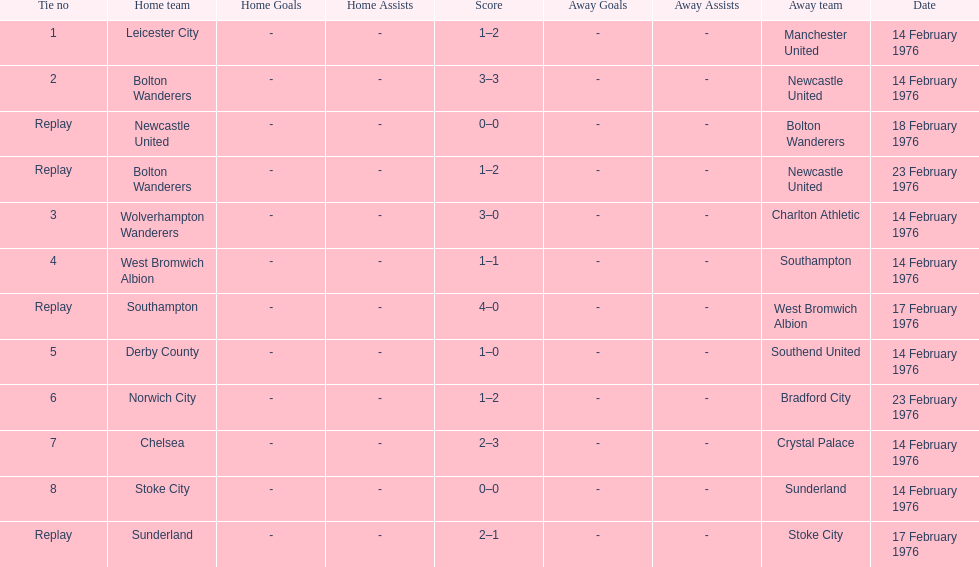What is the difference between southampton's score and sunderland's score? 2 goals. 